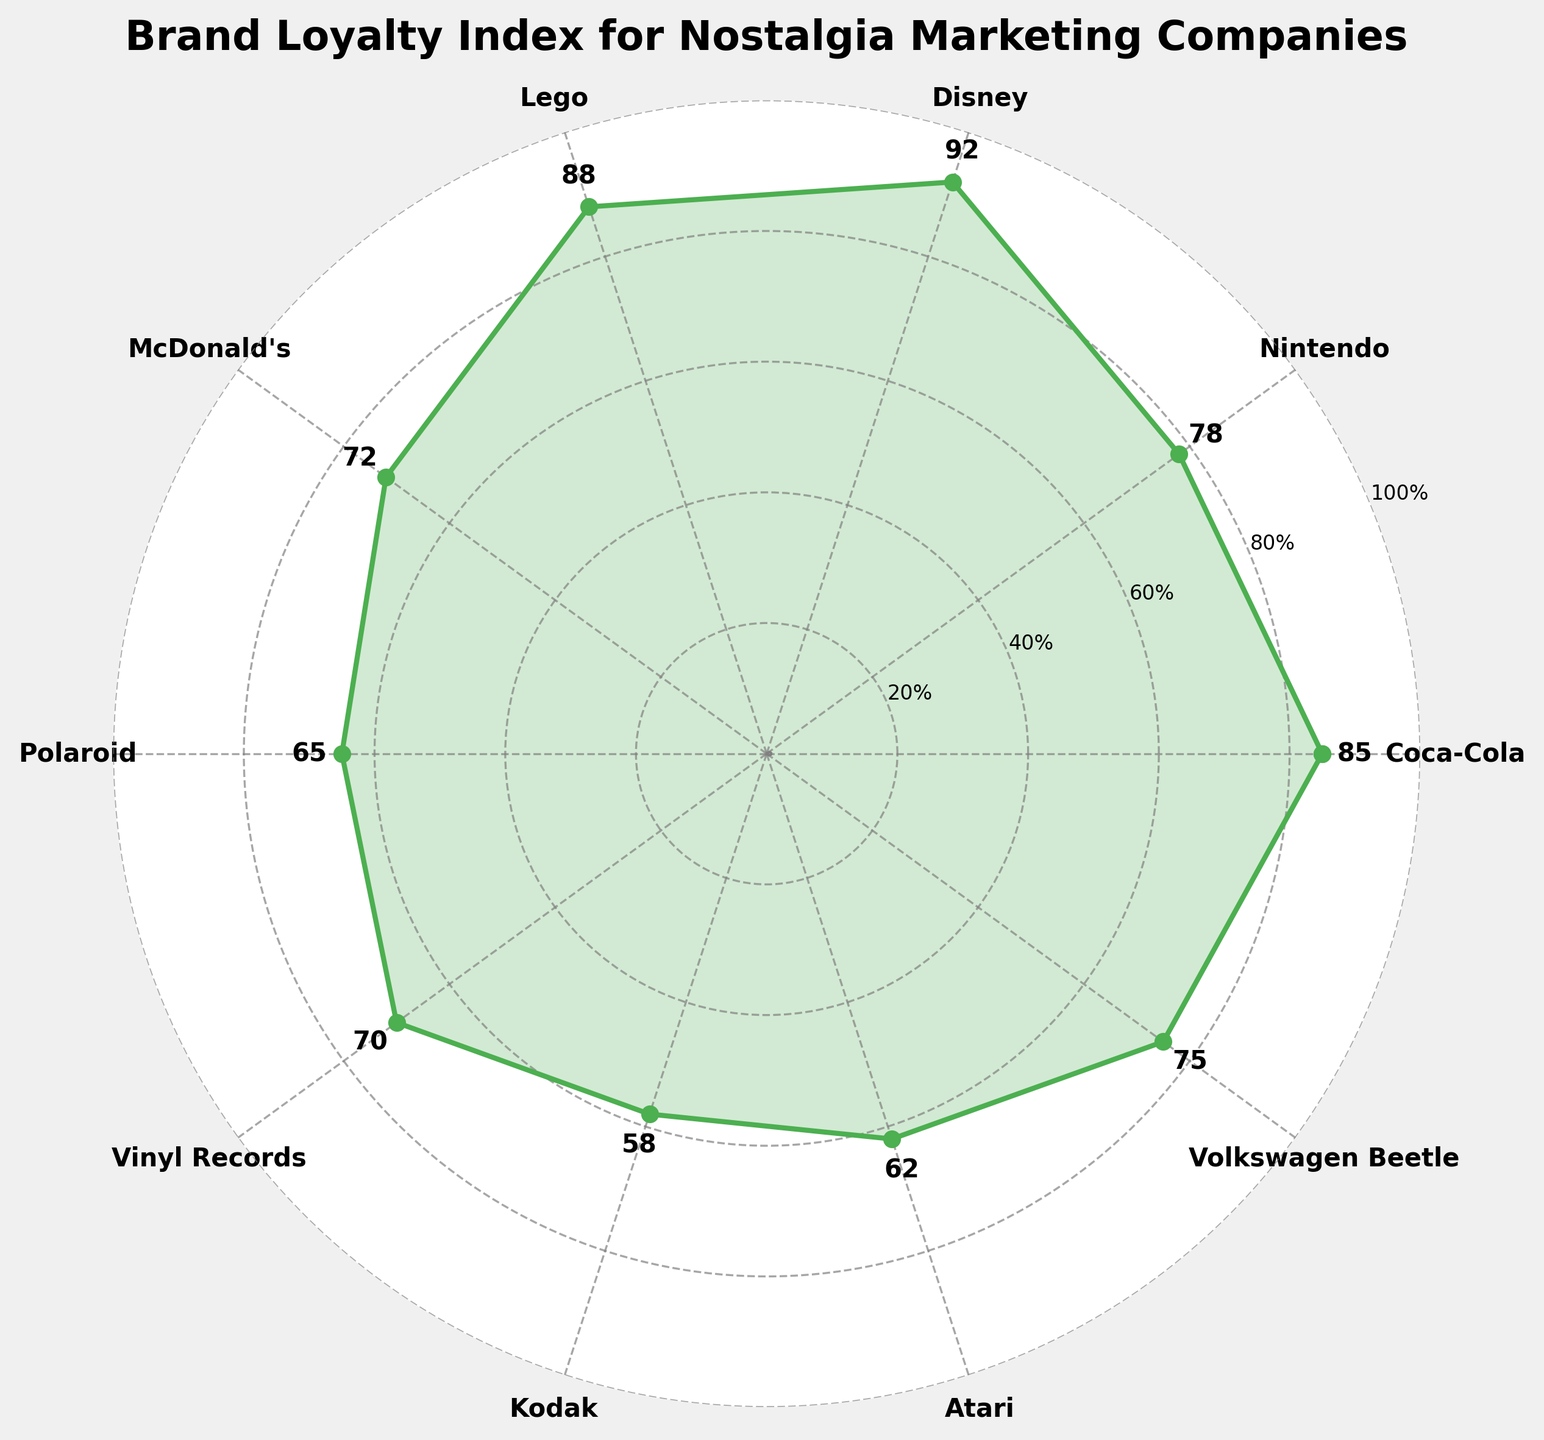What's the title of the chart? The title is located at the top of the figure. It provides an overview of the content or the subject matter being depicted.
Answer: Brand Loyalty Index for Nostalgia Marketing Companies Which company has the highest Brand Loyalty Index? By looking at the plotted points and labels, it's clear which company's label corresponds to the highest radial value on the chart.
Answer: Disney Which company has the lowest Brand Loyalty Index? Identify the company whose plotted point is the closest to the center of the gauge chart, indicating the lowest Brand Loyalty Index.
Answer: Kodak What is the Brand Loyalty Index of Lego? Find and read the value label next to Lego's data point on the chart.
Answer: 88 How many companies have a Brand Loyalty Index over 80? Count the number of companies whose data points have radial values higher than 80.
Answer: 3 What is the average Brand Loyalty Index of all the companies? Sum the Brand Loyalty Indices of all the companies and divide by the number of companies: (85+78+92+88+72+65+70+58+62+75)/10.
Answer: 74.5 Is the Brand Loyalty Index of Coca-Cola greater than that of McDonald's? Compare the radial values of Coca-Cola and McDonald's on the chart.
Answer: Yes What's the difference in Brand Loyalty Index between the highest and lowest company? Subtract the lowest Brand Loyalty Index value from the highest: 92 (Disney) - 58 (Kodak).
Answer: 34 Which company has a Brand Loyalty Index closest to the average? Calculate the average Brand Loyalty Index and find the company with a value closest to this average. Average is 74.5, closest is Volkswagen Beetle with 75.
Answer: Volkswagen Beetle 